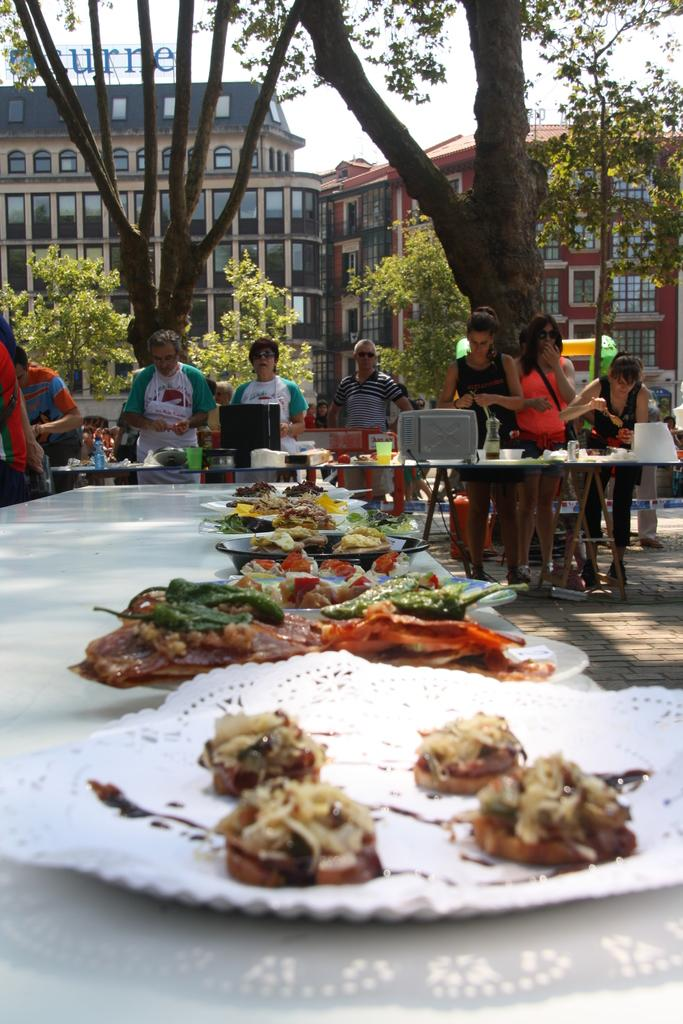How many people can be seen in the image? There are people in the image, but the exact number is not specified. What type of furniture is present in the image? There are tables in the image. What items are on the tables? Bottles, plates, and food items are on the tables. What can be seen in the background of the image? There are trees, buildings, and the sky visible in the background of the image. What type of nose can be seen on the person in the image? There is no specific person mentioned in the image, and therefore no nose can be identified. 